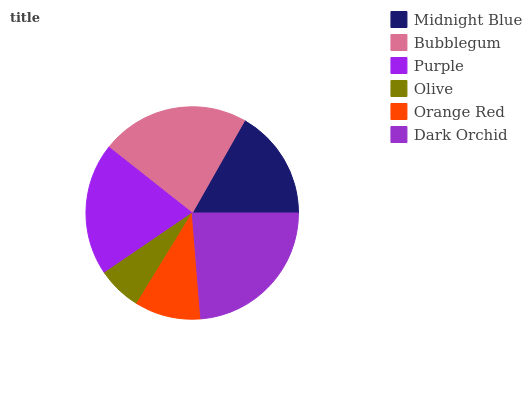Is Olive the minimum?
Answer yes or no. Yes. Is Dark Orchid the maximum?
Answer yes or no. Yes. Is Bubblegum the minimum?
Answer yes or no. No. Is Bubblegum the maximum?
Answer yes or no. No. Is Bubblegum greater than Midnight Blue?
Answer yes or no. Yes. Is Midnight Blue less than Bubblegum?
Answer yes or no. Yes. Is Midnight Blue greater than Bubblegum?
Answer yes or no. No. Is Bubblegum less than Midnight Blue?
Answer yes or no. No. Is Purple the high median?
Answer yes or no. Yes. Is Midnight Blue the low median?
Answer yes or no. Yes. Is Midnight Blue the high median?
Answer yes or no. No. Is Bubblegum the low median?
Answer yes or no. No. 